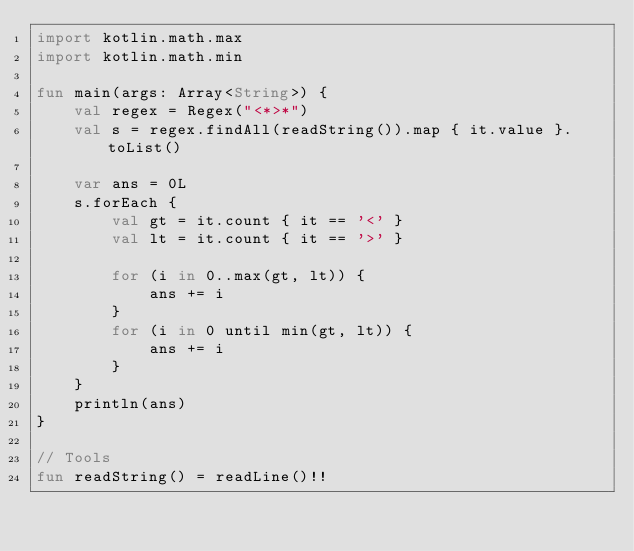<code> <loc_0><loc_0><loc_500><loc_500><_Kotlin_>import kotlin.math.max
import kotlin.math.min

fun main(args: Array<String>) {
    val regex = Regex("<*>*")
    val s = regex.findAll(readString()).map { it.value }.toList()

    var ans = 0L
    s.forEach {
        val gt = it.count { it == '<' }
        val lt = it.count { it == '>' }

        for (i in 0..max(gt, lt)) {
            ans += i
        }
        for (i in 0 until min(gt, lt)) {
            ans += i
        }
    }
    println(ans)
}

// Tools
fun readString() = readLine()!!</code> 